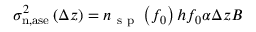<formula> <loc_0><loc_0><loc_500><loc_500>\begin{array} { r } { \sigma _ { n , a s e } ^ { 2 } \left ( \Delta z \right ) = n _ { s p } \left ( f _ { 0 } \right ) h f _ { 0 } \alpha \Delta z B } \end{array}</formula> 